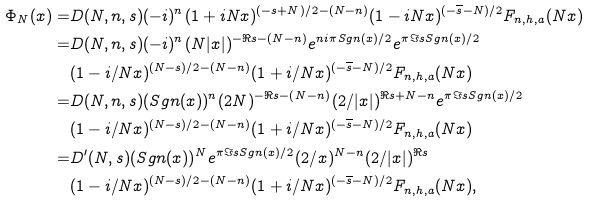<formula> <loc_0><loc_0><loc_500><loc_500>\Phi _ { N } ( x ) = & D ( N , n , s ) ( - i ) ^ { n } ( 1 + i N x ) ^ { ( - s + N ) / 2 - ( N - n ) } ( 1 - i N x ) ^ { ( - \overline { s } - N ) / 2 } F _ { n , h , a } ( N x ) \\ = & D ( N , n , s ) ( - i ) ^ { n } ( N | x | ) ^ { - \Re { s } - ( N - n ) } e ^ { n i \pi S g n ( x ) / 2 } e ^ { \pi \Im { s } S g n ( x ) / 2 } \\ & ( 1 - i / N x ) ^ { ( N - s ) / 2 - ( N - n ) } ( 1 + i / N x ) ^ { ( - \overline { s } - N ) / 2 } F _ { n , h , a } ( N x ) \\ = & D ( N , n , s ) ( S g n ( x ) ) ^ { n } ( 2 N ) ^ { - \Re { s } - ( N - n ) } ( 2 / | x | ) ^ { \Re { s } + N - n } e ^ { \pi \Im { s } S g n ( x ) / 2 } \\ & ( 1 - i / N x ) ^ { ( N - s ) / 2 - ( N - n ) } ( 1 + i / N x ) ^ { ( - \overline { s } - N ) / 2 } F _ { n , h , a } ( N x ) \\ = & D ^ { \prime } ( N , s ) ( S g n ( x ) ) ^ { N } e ^ { \pi \Im { s } S g n ( x ) / 2 } ( 2 / x ) ^ { N - n } ( 2 / | x | ) ^ { \Re { s } } \\ & ( 1 - i / N x ) ^ { ( N - s ) / 2 - ( N - n ) } ( 1 + i / N x ) ^ { ( - \overline { s } - N ) / 2 } F _ { n , h , a } ( N x ) ,</formula> 